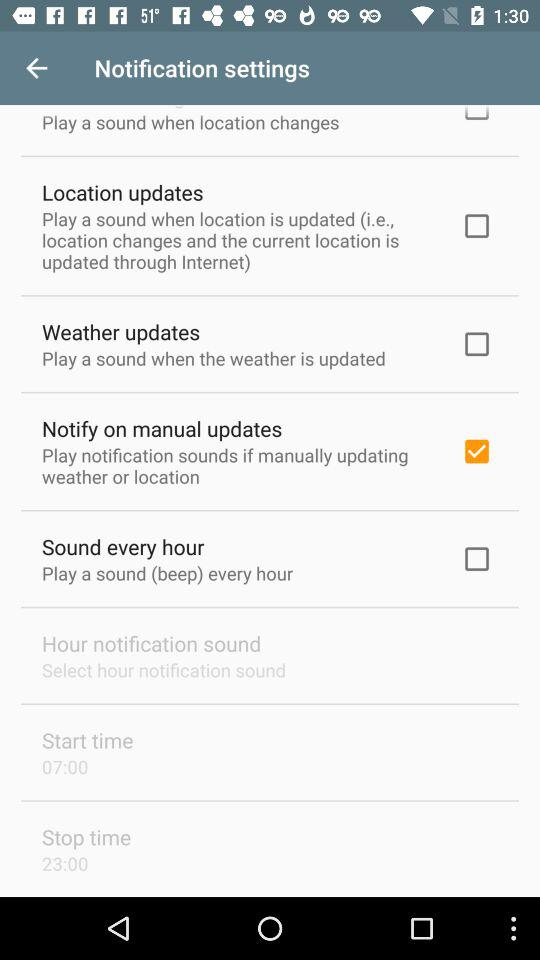What is the status of "Notify on manual updates"? The status is "on". 